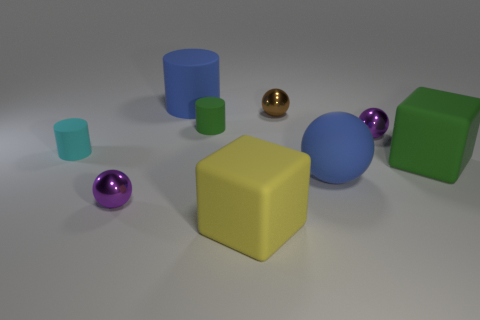What is the shape of the tiny object that is in front of the green matte cylinder and right of the yellow thing? The tiny object in front of the green matte cylinder and to the right of the yellow cube is indeed spherical. It appears to be a small, polished golden sphere reflecting light, which contrasts with the different textures and shapes around it. 